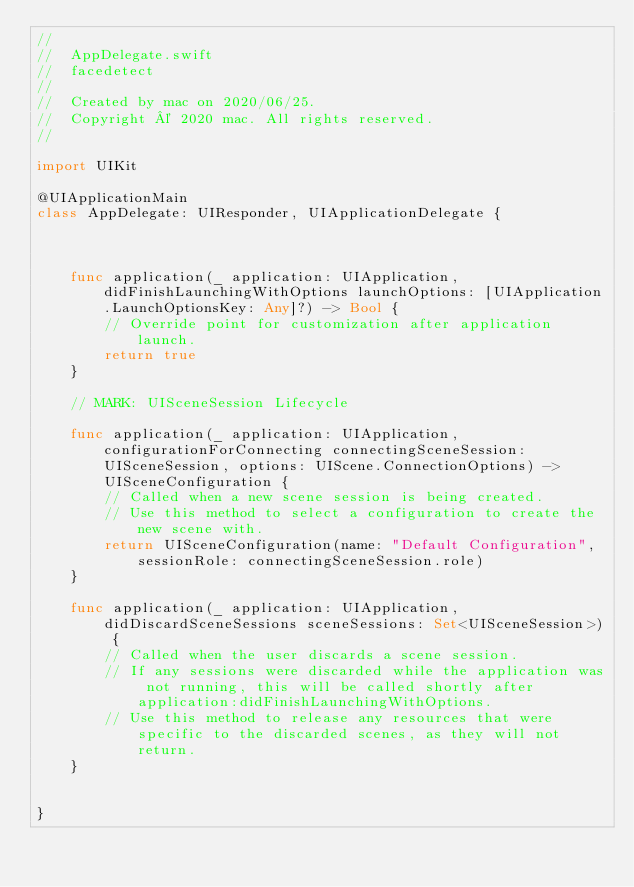<code> <loc_0><loc_0><loc_500><loc_500><_Swift_>//
//  AppDelegate.swift
//  facedetect
//
//  Created by mac on 2020/06/25.
//  Copyright © 2020 mac. All rights reserved.
//

import UIKit

@UIApplicationMain
class AppDelegate: UIResponder, UIApplicationDelegate {



    func application(_ application: UIApplication, didFinishLaunchingWithOptions launchOptions: [UIApplication.LaunchOptionsKey: Any]?) -> Bool {
        // Override point for customization after application launch.
        return true
    }

    // MARK: UISceneSession Lifecycle

    func application(_ application: UIApplication, configurationForConnecting connectingSceneSession: UISceneSession, options: UIScene.ConnectionOptions) -> UISceneConfiguration {
        // Called when a new scene session is being created.
        // Use this method to select a configuration to create the new scene with.
        return UISceneConfiguration(name: "Default Configuration", sessionRole: connectingSceneSession.role)
    }

    func application(_ application: UIApplication, didDiscardSceneSessions sceneSessions: Set<UISceneSession>) {
        // Called when the user discards a scene session.
        // If any sessions were discarded while the application was not running, this will be called shortly after application:didFinishLaunchingWithOptions.
        // Use this method to release any resources that were specific to the discarded scenes, as they will not return.
    }


}

</code> 